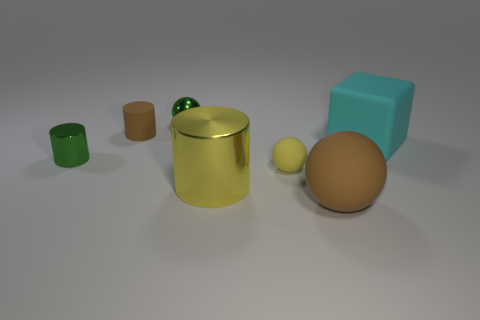Subtract all tiny matte cylinders. How many cylinders are left? 2 Add 3 cyan rubber cubes. How many objects exist? 10 Subtract all brown spheres. How many spheres are left? 2 Subtract 1 balls. How many balls are left? 2 Add 1 green rubber blocks. How many green rubber blocks exist? 1 Subtract 0 blue spheres. How many objects are left? 7 Subtract all spheres. How many objects are left? 4 Subtract all purple blocks. Subtract all cyan spheres. How many blocks are left? 1 Subtract all gray cylinders. How many purple spheres are left? 0 Subtract all large cyan shiny objects. Subtract all big cyan things. How many objects are left? 6 